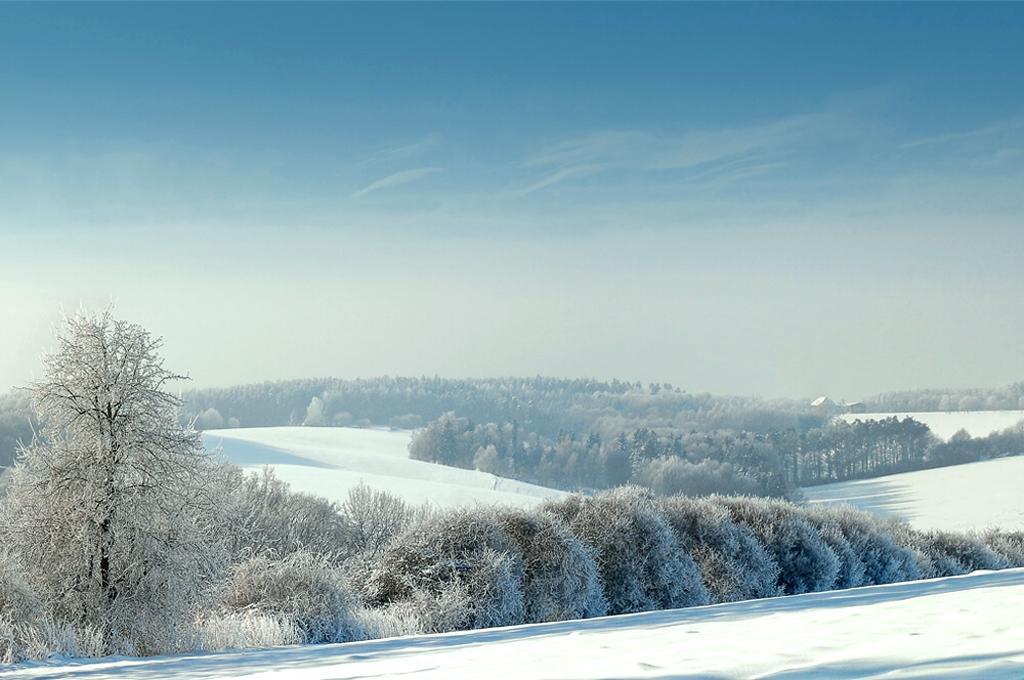Can you describe this image briefly? In this image I can see few trees covered with snow. In the background the sky is in white and blue color. 